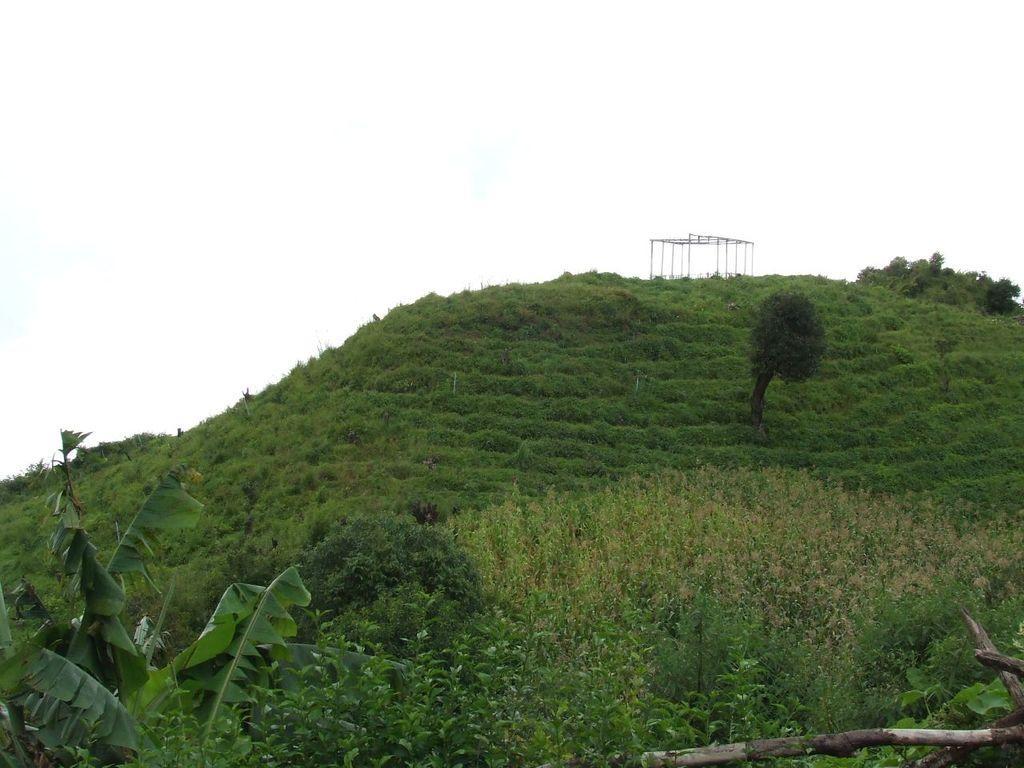In one or two sentences, can you explain what this image depicts? This image is clicked outside. There are trees at the bottom and middle. There is sky at the top. This looks like a hilly area. 